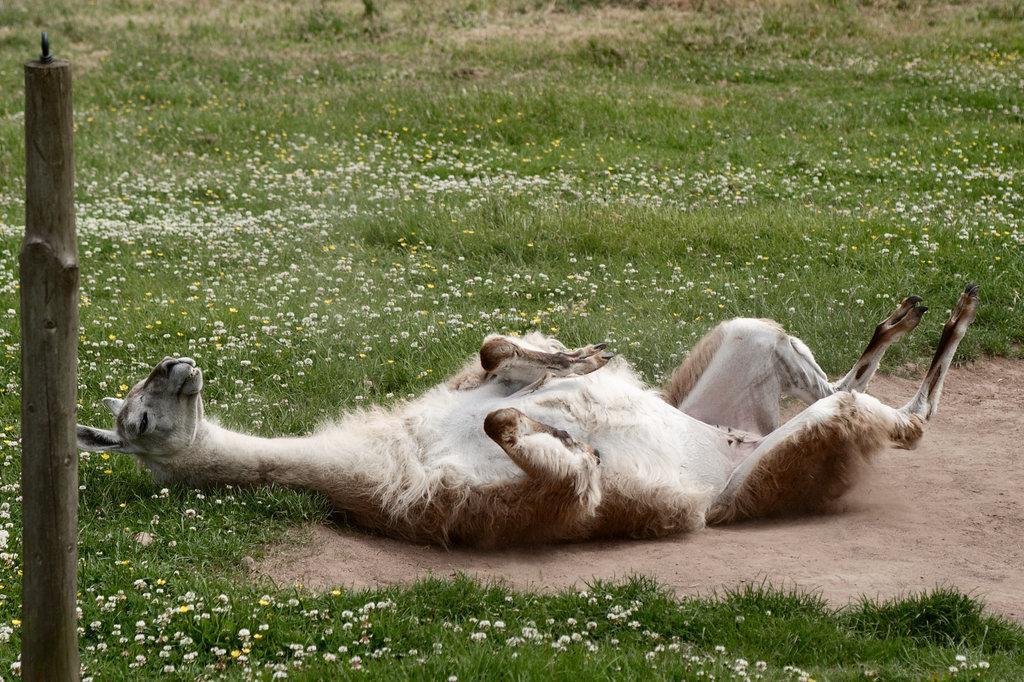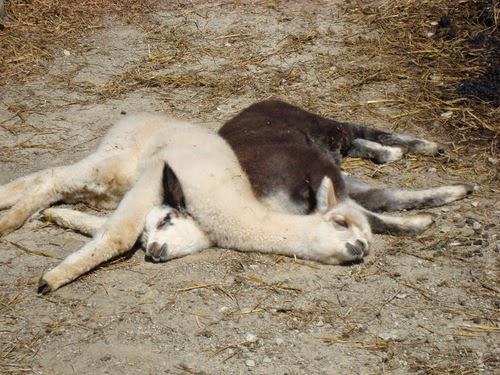The first image is the image on the left, the second image is the image on the right. Considering the images on both sides, is "All llamas are lying on the ground, and at least one llama is lying with the side of its head on the ground." valid? Answer yes or no. Yes. The first image is the image on the left, the second image is the image on the right. Evaluate the accuracy of this statement regarding the images: "There are two llamas in one image and one llama in the other.". Is it true? Answer yes or no. Yes. 